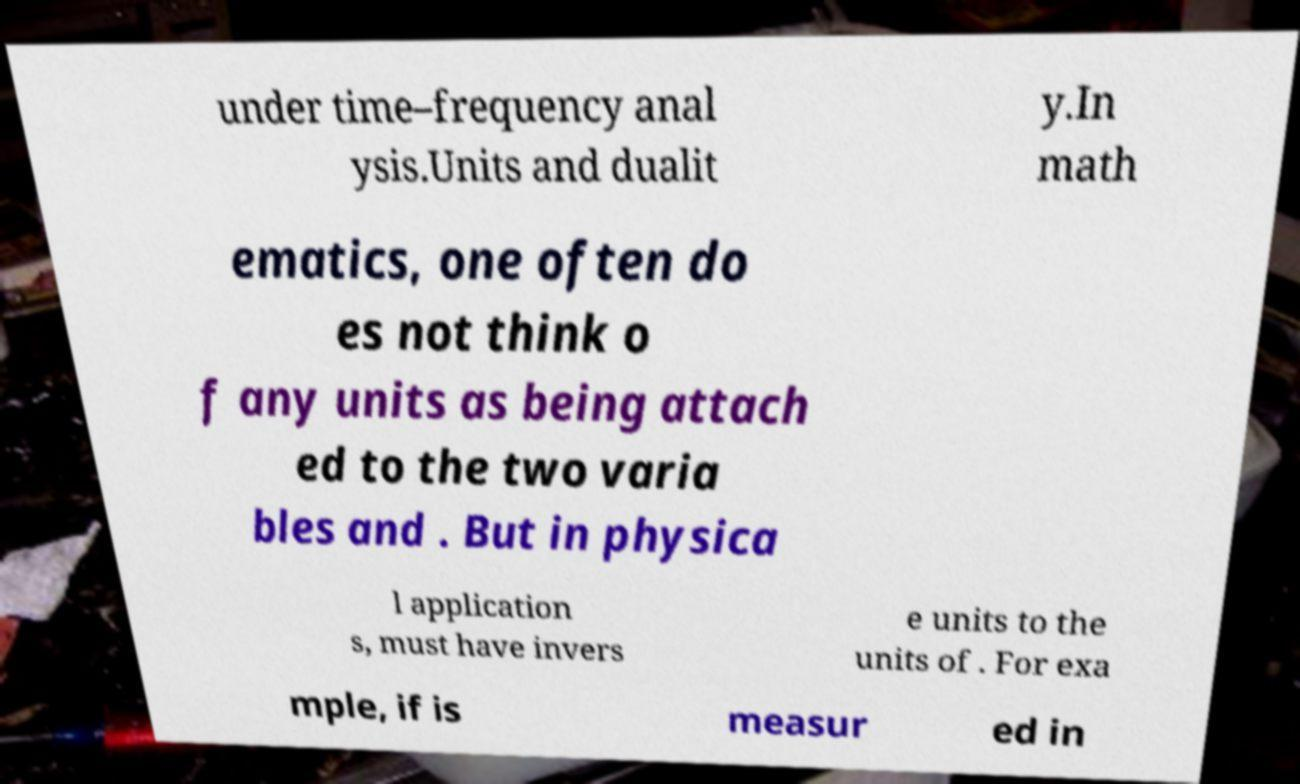Can you read and provide the text displayed in the image?This photo seems to have some interesting text. Can you extract and type it out for me? under time–frequency anal ysis.Units and dualit y.In math ematics, one often do es not think o f any units as being attach ed to the two varia bles and . But in physica l application s, must have invers e units to the units of . For exa mple, if is measur ed in 